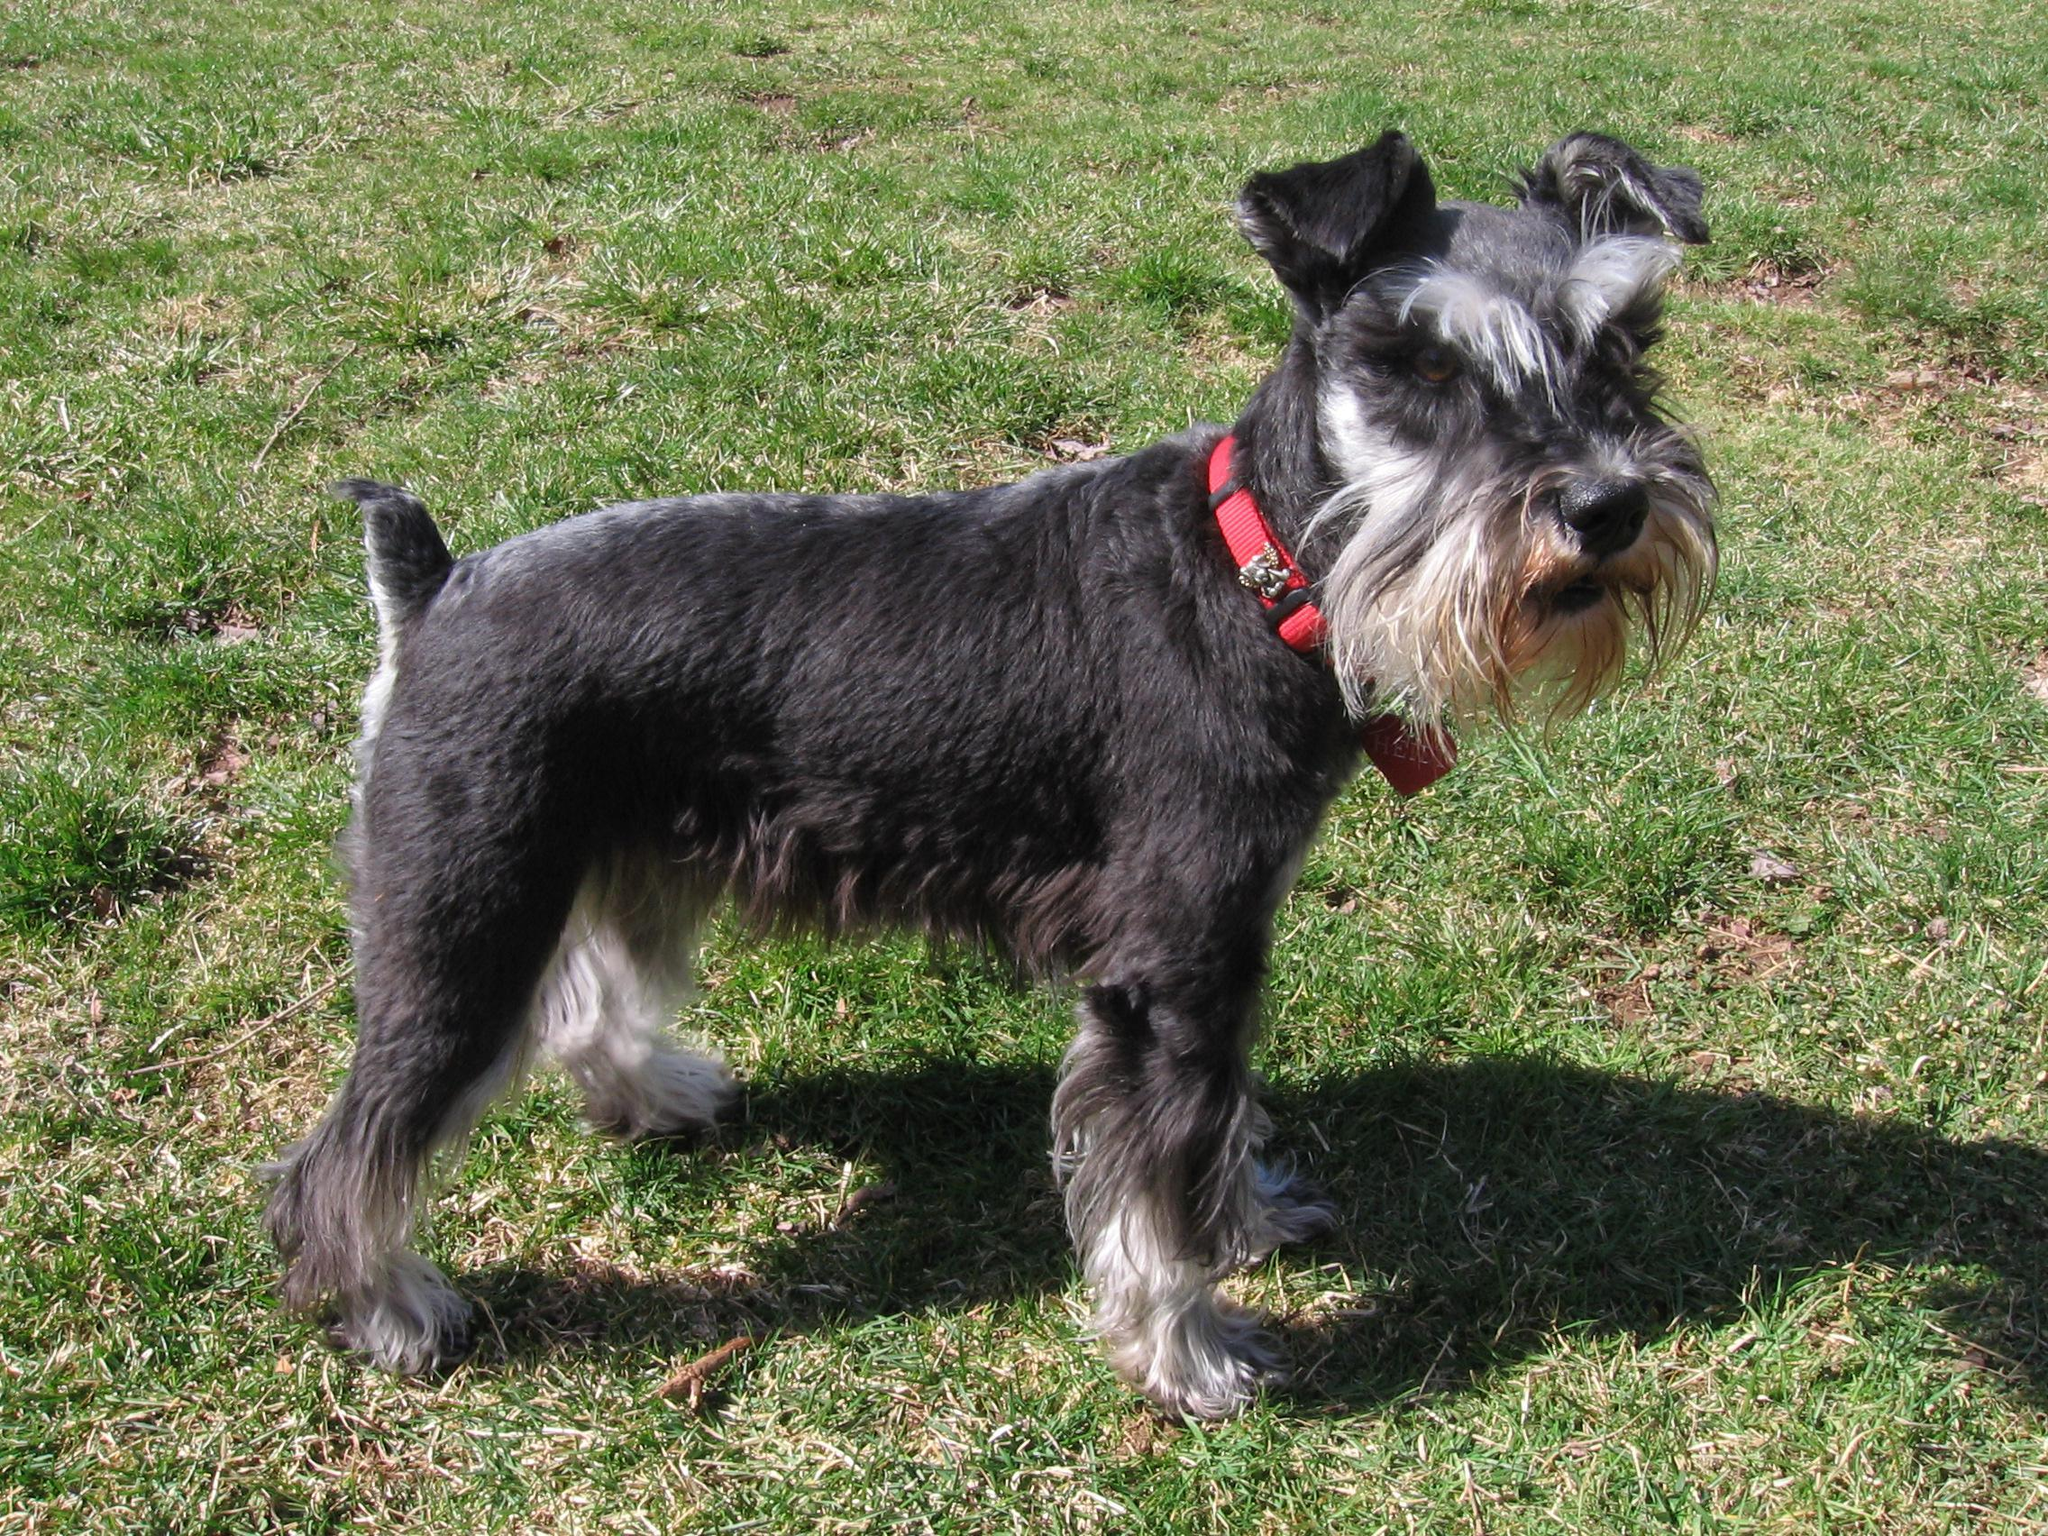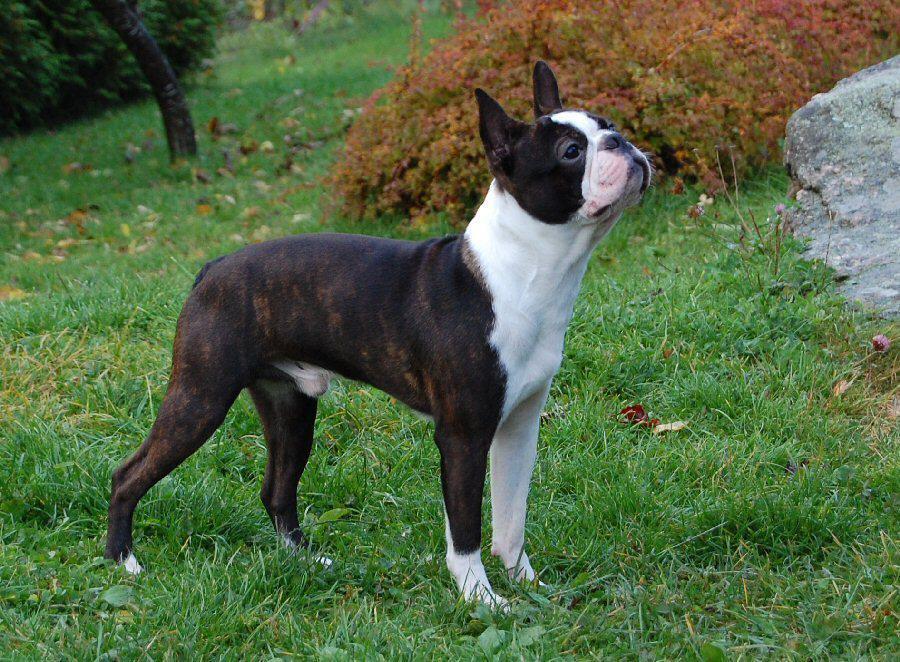The first image is the image on the left, the second image is the image on the right. For the images displayed, is the sentence "Both dogs are standing on the grass." factually correct? Answer yes or no. Yes. The first image is the image on the left, the second image is the image on the right. Evaluate the accuracy of this statement regarding the images: "One dog has a red collar.". Is it true? Answer yes or no. Yes. The first image is the image on the left, the second image is the image on the right. Assess this claim about the two images: "Both images contain exactly one dog that is standing on grass.". Correct or not? Answer yes or no. Yes. The first image is the image on the left, the second image is the image on the right. Considering the images on both sides, is "Only one little dog is wearing a collar." valid? Answer yes or no. Yes. 